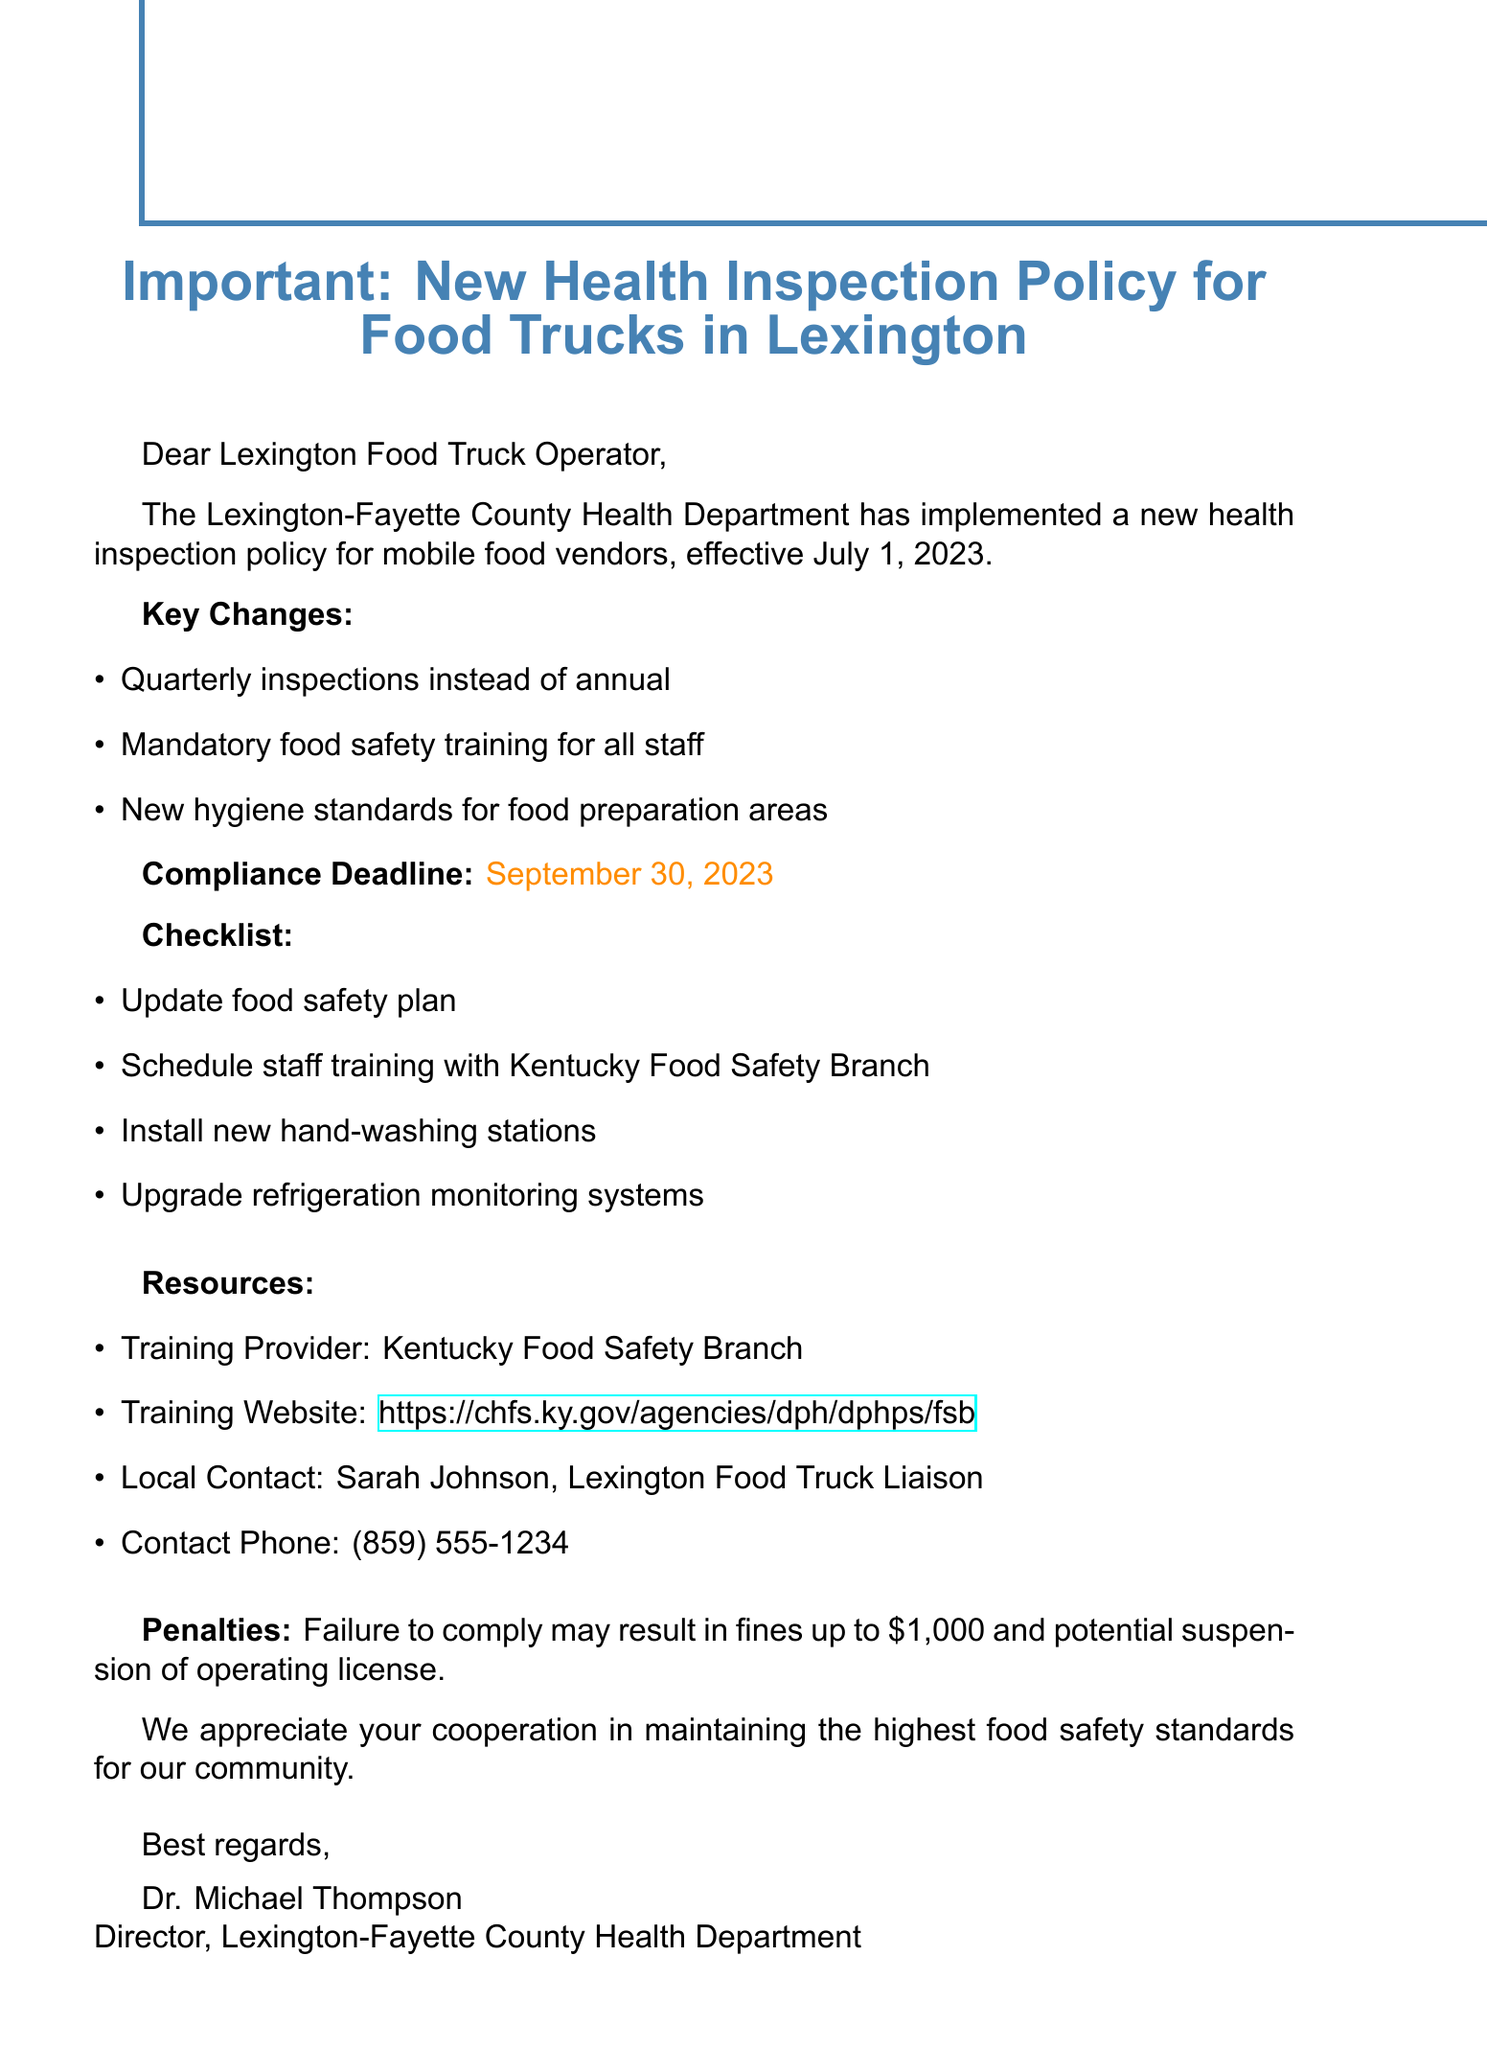What is the subject of the email? The subject line of the email specifies the main topic being addressed, which is about the new health inspection policy for food trucks.
Answer: Important: New Health Inspection Policy for Food Trucks in Lexington What is the compliance deadline? The compliance deadline is the final date by which food truck operators need to meet the new health inspection policy requirements.
Answer: September 30, 2023 Who is the local contact for mobile food vendors? The email provides a specific contact person for any inquiries related to the health inspection policy for food trucks.
Answer: Sarah Johnson, Lexington Food Truck Liaison What are the key changes in inspection frequency? Key changes include a shift from annual to more frequent inspections, which emphasizes increased oversight.
Answer: Quarterly inspections instead of annual What penalty may result from non-compliance? The email outlines a specific consequence for failing to adhere to the new policy, indicating the seriousness of compliance.
Answer: Fines up to $1,000 and potential suspension of operating license What is the training provider mentioned in the email? The name of the organization responsible for providing food safety training is specified in the resources section.
Answer: Kentucky Food Safety Branch How many items are included in the compliance checklist? The checklist helps operators know what actions to take to comply, and the number of items indicates the scope of necessary compliance actions.
Answer: Four items What new requirement is imposed for staff? The email indicates a crucial new requirement that every food vendor must comply with regarding their employees.
Answer: Mandatory food safety training for all staff What is the training website link? The email includes a specific online resource where food truck operators can find information related to training.
Answer: https://chfs.ky.gov/agencies/dph/dphps/fsb 